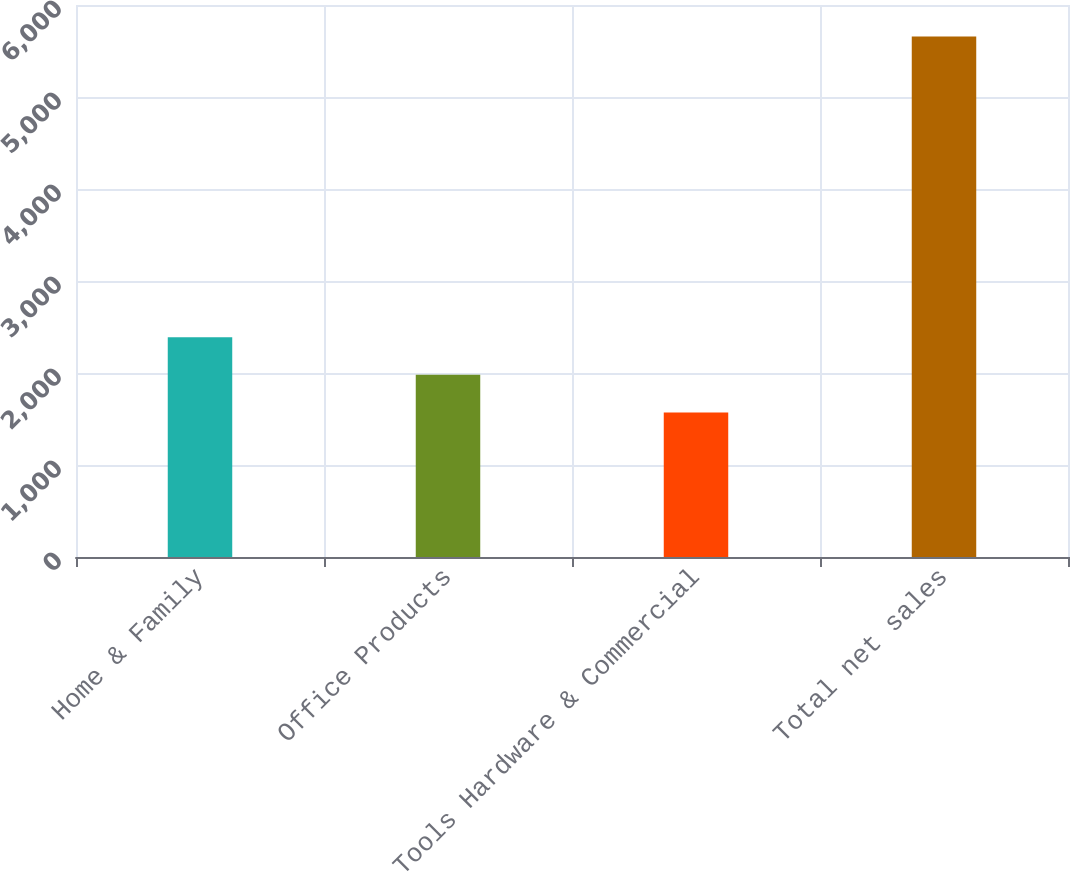Convert chart to OTSL. <chart><loc_0><loc_0><loc_500><loc_500><bar_chart><fcel>Home & Family<fcel>Office Products<fcel>Tools Hardware & Commercial<fcel>Total net sales<nl><fcel>2388.36<fcel>1979.63<fcel>1570.9<fcel>5658.2<nl></chart> 